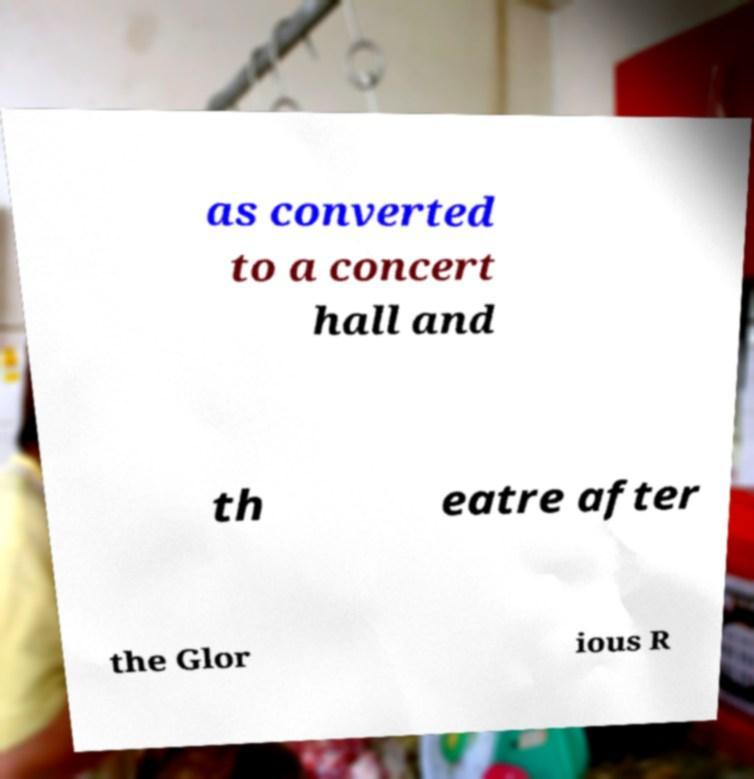Please read and relay the text visible in this image. What does it say? as converted to a concert hall and th eatre after the Glor ious R 